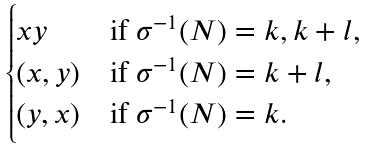Convert formula to latex. <formula><loc_0><loc_0><loc_500><loc_500>\begin{cases} x y & \text {if } \sigma ^ { - 1 } ( N ) = k , k + l , \\ ( x , y ) & \text {if } \sigma ^ { - 1 } ( N ) = k + l , \\ ( y , x ) & \text {if } \sigma ^ { - 1 } ( N ) = k . \end{cases}</formula> 